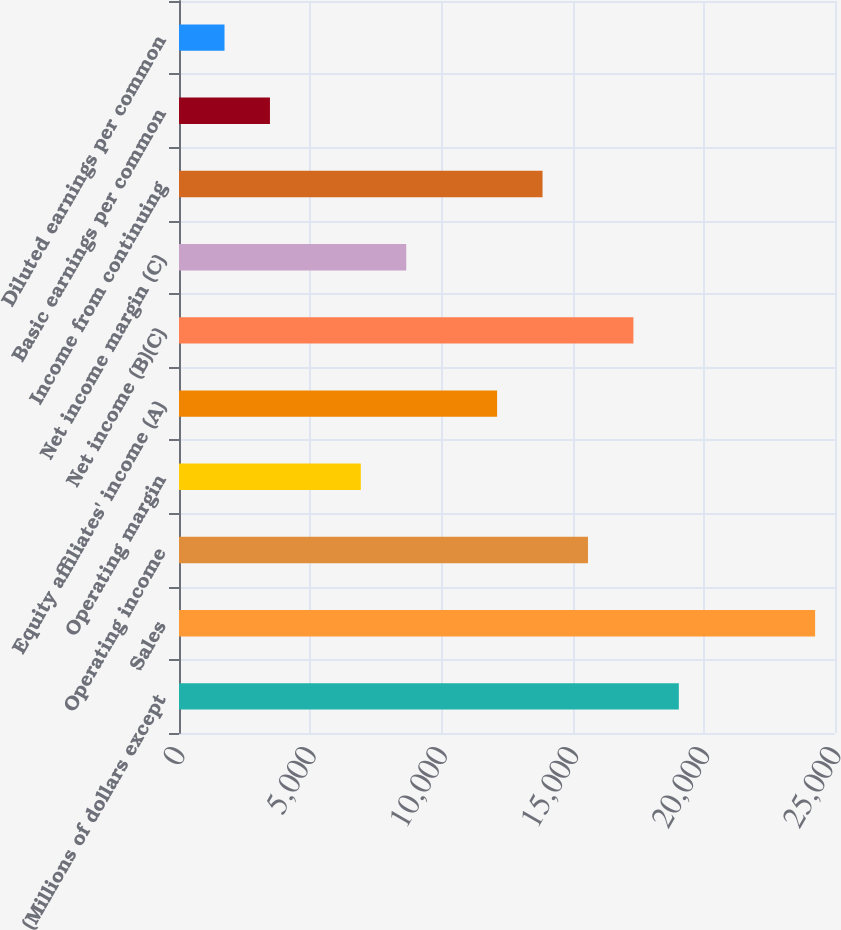Convert chart. <chart><loc_0><loc_0><loc_500><loc_500><bar_chart><fcel>(Millions of dollars except<fcel>Sales<fcel>Operating income<fcel>Operating margin<fcel>Equity affiliates' income (A)<fcel>Net income (B)(C)<fcel>Net income margin (C)<fcel>Income from continuing<fcel>Basic earnings per common<fcel>Diluted earnings per common<nl><fcel>19048.4<fcel>24242.5<fcel>15585.6<fcel>6928.72<fcel>12122.9<fcel>17317<fcel>8660.1<fcel>13854.2<fcel>3465.96<fcel>1734.58<nl></chart> 